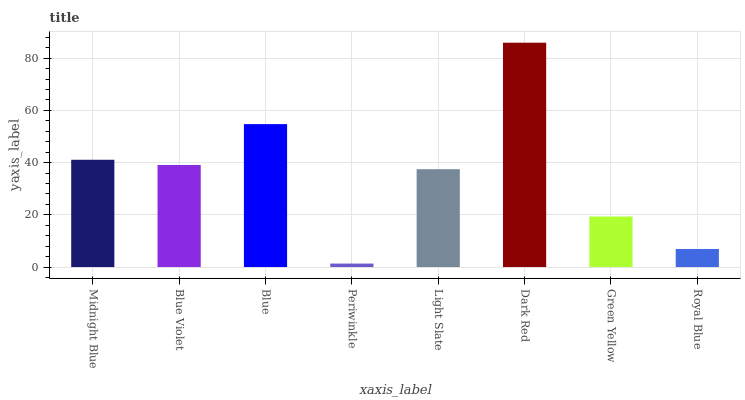Is Blue Violet the minimum?
Answer yes or no. No. Is Blue Violet the maximum?
Answer yes or no. No. Is Midnight Blue greater than Blue Violet?
Answer yes or no. Yes. Is Blue Violet less than Midnight Blue?
Answer yes or no. Yes. Is Blue Violet greater than Midnight Blue?
Answer yes or no. No. Is Midnight Blue less than Blue Violet?
Answer yes or no. No. Is Blue Violet the high median?
Answer yes or no. Yes. Is Light Slate the low median?
Answer yes or no. Yes. Is Periwinkle the high median?
Answer yes or no. No. Is Periwinkle the low median?
Answer yes or no. No. 